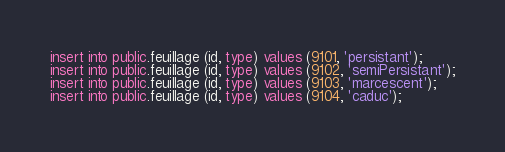Convert code to text. <code><loc_0><loc_0><loc_500><loc_500><_SQL_>insert into public.feuillage (id, type) values (9101, 'persistant');
insert into public.feuillage (id, type) values (9102, 'semiPersistant');
insert into public.feuillage (id, type) values (9103, 'marcescent');
insert into public.feuillage (id, type) values (9104, 'caduc');
</code> 